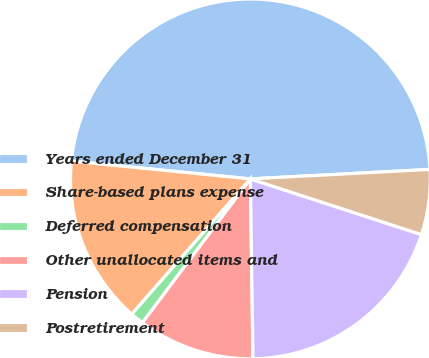Convert chart. <chart><loc_0><loc_0><loc_500><loc_500><pie_chart><fcel>Years ended December 31<fcel>Share-based plans expense<fcel>Deferred compensation<fcel>Other unallocated items and<fcel>Pension<fcel>Postretirement<nl><fcel>47.58%<fcel>15.12%<fcel>1.21%<fcel>10.48%<fcel>19.76%<fcel>5.85%<nl></chart> 